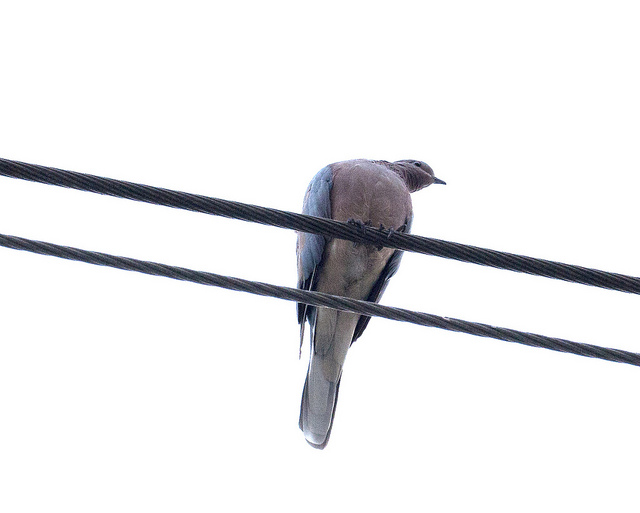<image>What type of bird is this? I don't know what type of bird this is. It could be a dove, robin, pigeon, or canary. Is the bird provoked by a predator? I don't know if the bird is provoked by a predator. What type of bird is this? I am not sure what type of bird this is. It can be a dove, robin, pigeon, or canary. Is the bird provoked by a predator? I don't know if the bird is provoked by a predator. It seems that the bird is not provoked by a predator. 